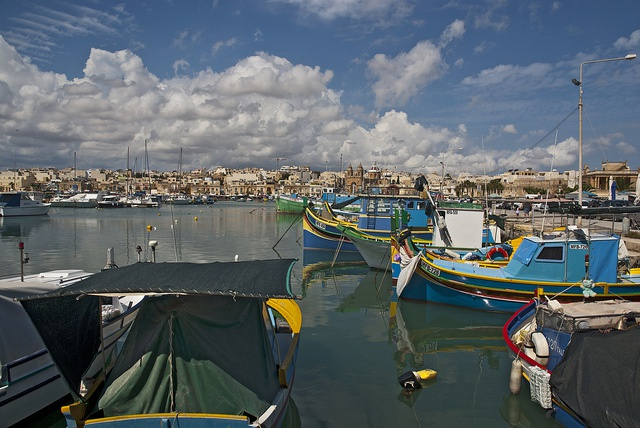Describe the objects in this image and their specific colors. I can see boat in darkblue, black, gray, purple, and darkgreen tones, boat in darkblue, black, teal, and blue tones, boat in darkblue, black, gray, darkgray, and navy tones, boat in darkblue, gray, blue, and black tones, and boat in darkblue, gray, black, and darkgreen tones in this image. 